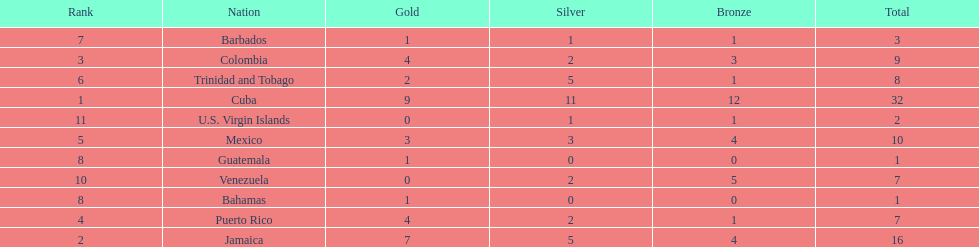Number of teams above 9 medals 3. 